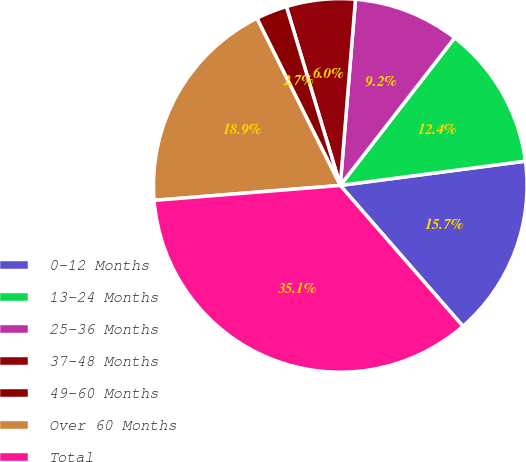Convert chart to OTSL. <chart><loc_0><loc_0><loc_500><loc_500><pie_chart><fcel>0-12 Months<fcel>13-24 Months<fcel>25-36 Months<fcel>37-48 Months<fcel>49-60 Months<fcel>Over 60 Months<fcel>Total<nl><fcel>15.67%<fcel>12.43%<fcel>9.19%<fcel>5.95%<fcel>2.71%<fcel>18.91%<fcel>35.12%<nl></chart> 